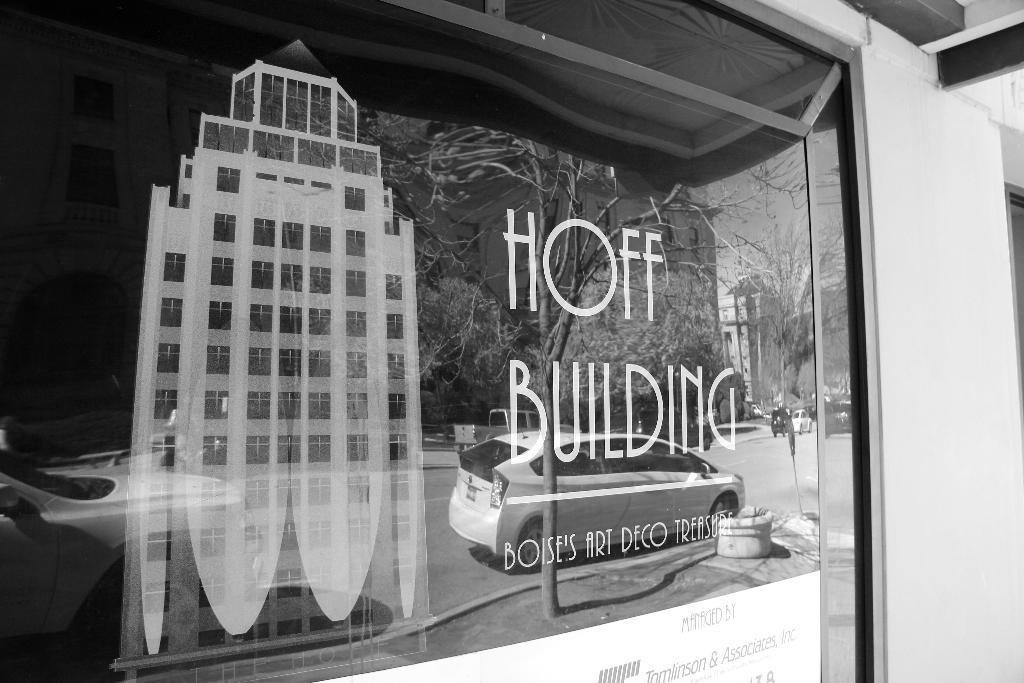In one or two sentences, can you explain what this image depicts? In this image in the foreground there is a glass door, on the door there is a text and depiction of building and through the door we could see reflection of vehicles, trees, buildings and road. And on the right side of the image there is wall. 